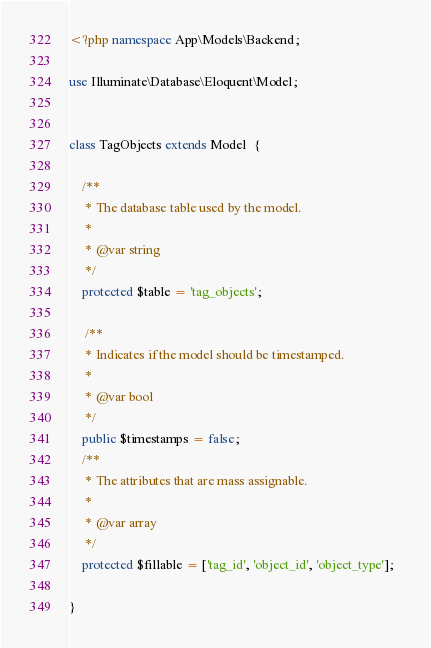<code> <loc_0><loc_0><loc_500><loc_500><_PHP_><?php namespace App\Models\Backend;

use Illuminate\Database\Eloquent\Model;


class TagObjects extends Model  {

	/**
	 * The database table used by the model.
	 *
	 * @var string
	 */
	protected $table = 'tag_objects';	

	 /**
     * Indicates if the model should be timestamped.
     *
     * @var bool
     */
    public $timestamps = false;
    /**
     * The attributes that are mass assignable.
     *
     * @var array
     */
    protected $fillable = ['tag_id', 'object_id', 'object_type'];  
    
}
</code> 